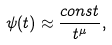Convert formula to latex. <formula><loc_0><loc_0><loc_500><loc_500>\psi ( t ) \approx \frac { c o n s t } { t ^ { \mu } } ,</formula> 